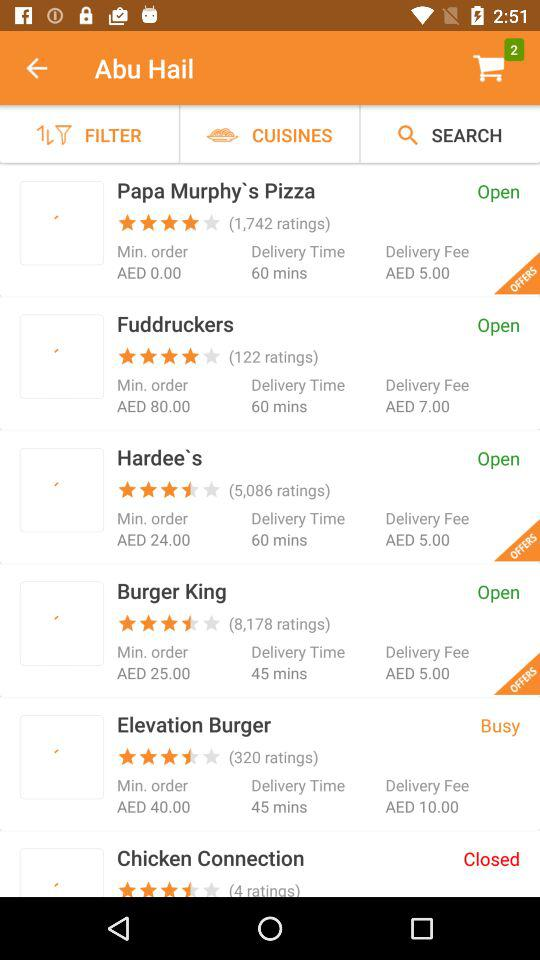What is the number of ratings for "Burger King"? There are 8,178 ratings for "Burger King". 